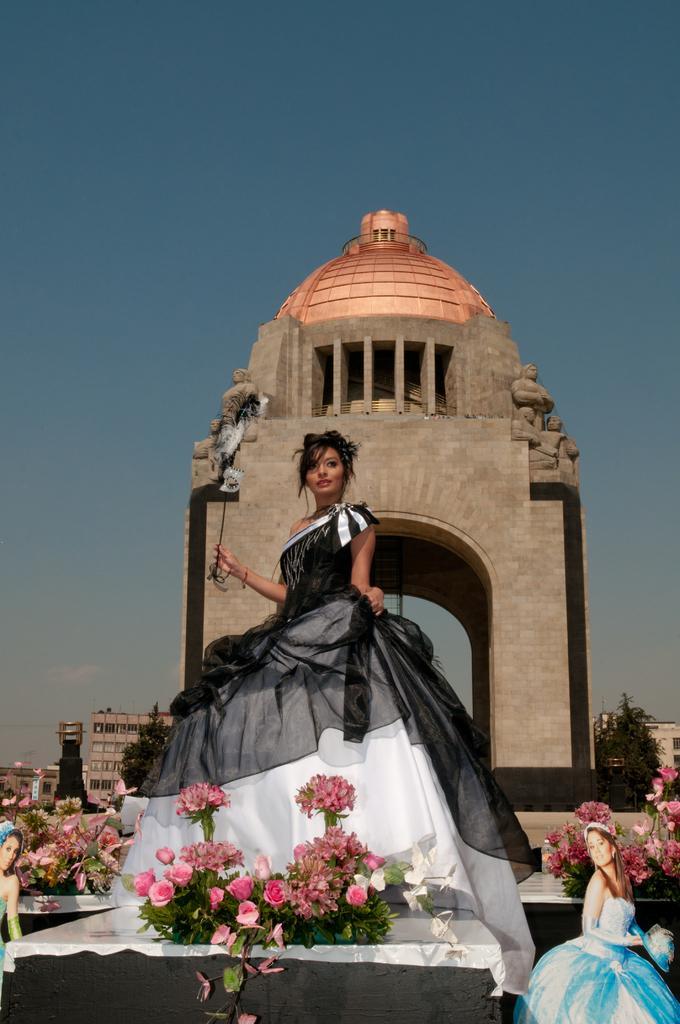How would you summarize this image in a sentence or two? There is a lady holding a stick in the foreground area of the image, there is an arch and a dome behind her. There are flowers and girls at the bottom side, there are buildings, trees and the sky in the background. 